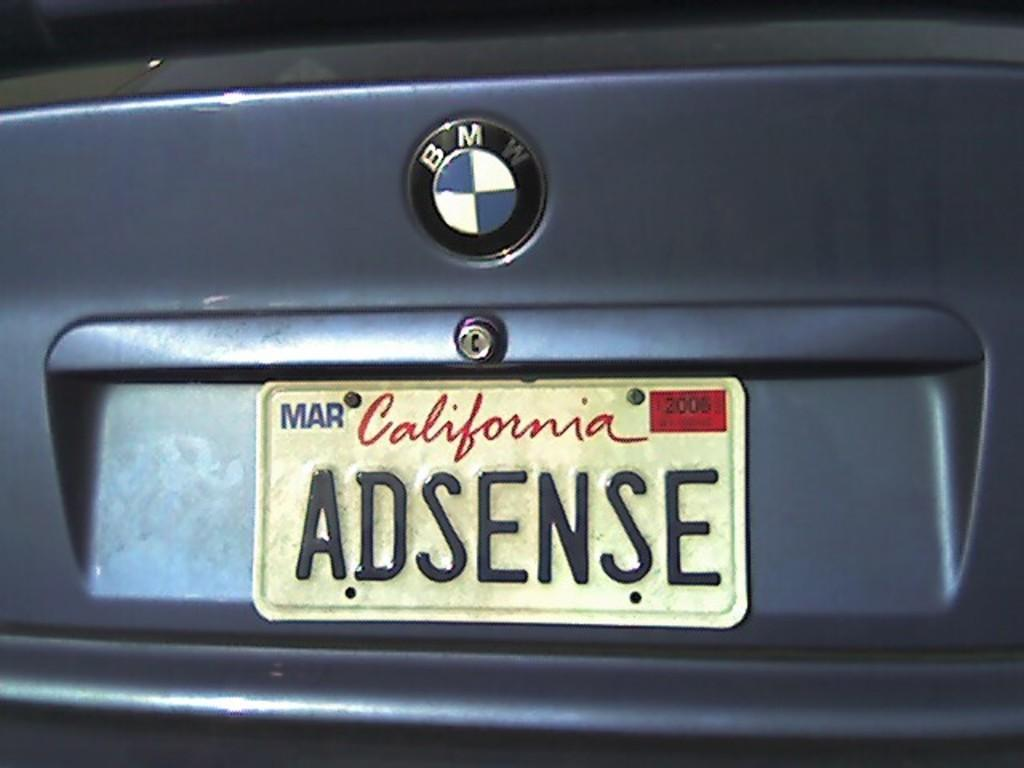<image>
Summarize the visual content of the image. a California license plate was adsense as the letters 